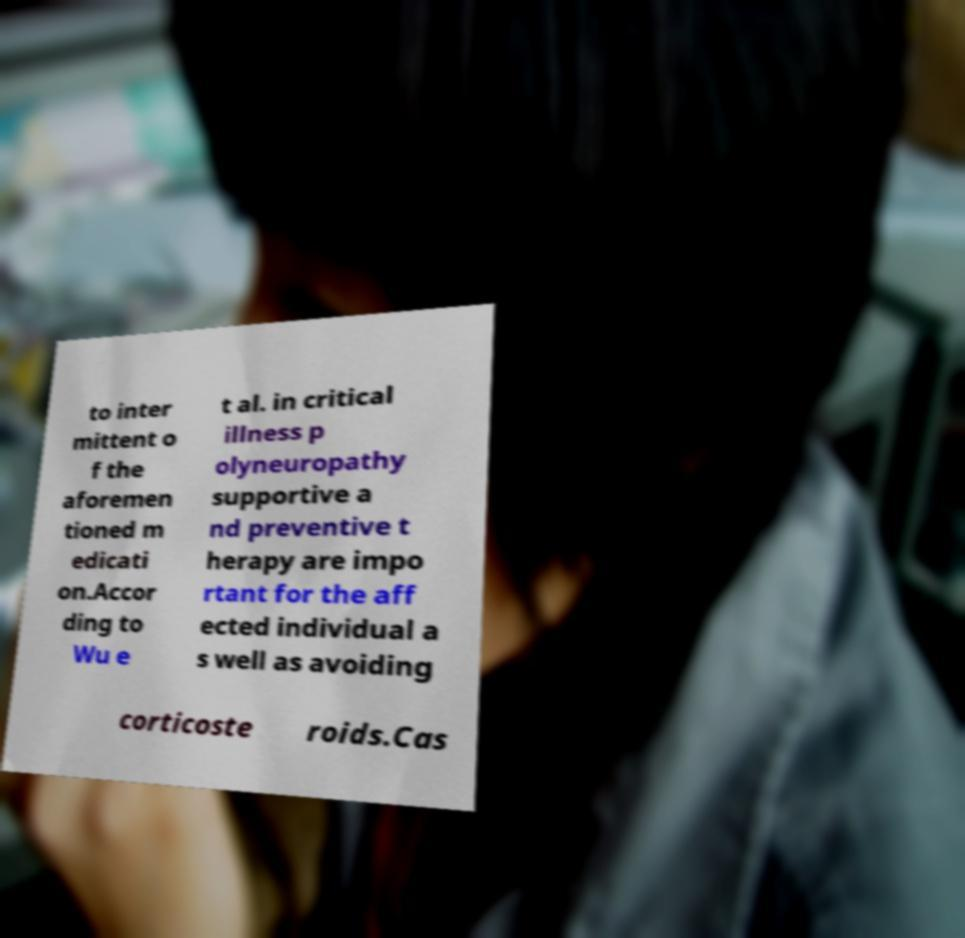For documentation purposes, I need the text within this image transcribed. Could you provide that? to inter mittent o f the aforemen tioned m edicati on.Accor ding to Wu e t al. in critical illness p olyneuropathy supportive a nd preventive t herapy are impo rtant for the aff ected individual a s well as avoiding corticoste roids.Cas 